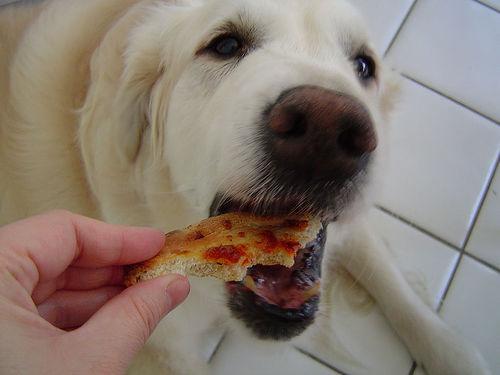How many dogs are there?
Give a very brief answer. 1. 